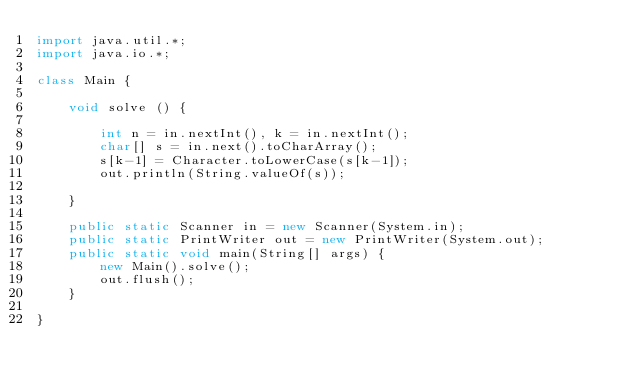Convert code to text. <code><loc_0><loc_0><loc_500><loc_500><_Java_>import java.util.*;
import java.io.*;

class Main {

	void solve () {

		int n = in.nextInt(), k = in.nextInt();
		char[] s = in.next().toCharArray();
		s[k-1] = Character.toLowerCase(s[k-1]);
		out.println(String.valueOf(s));
		
	}
	
	public static Scanner in = new Scanner(System.in);
	public static PrintWriter out = new PrintWriter(System.out);
	public static void main(String[] args) {
		new Main().solve();
		out.flush();
	}

}</code> 